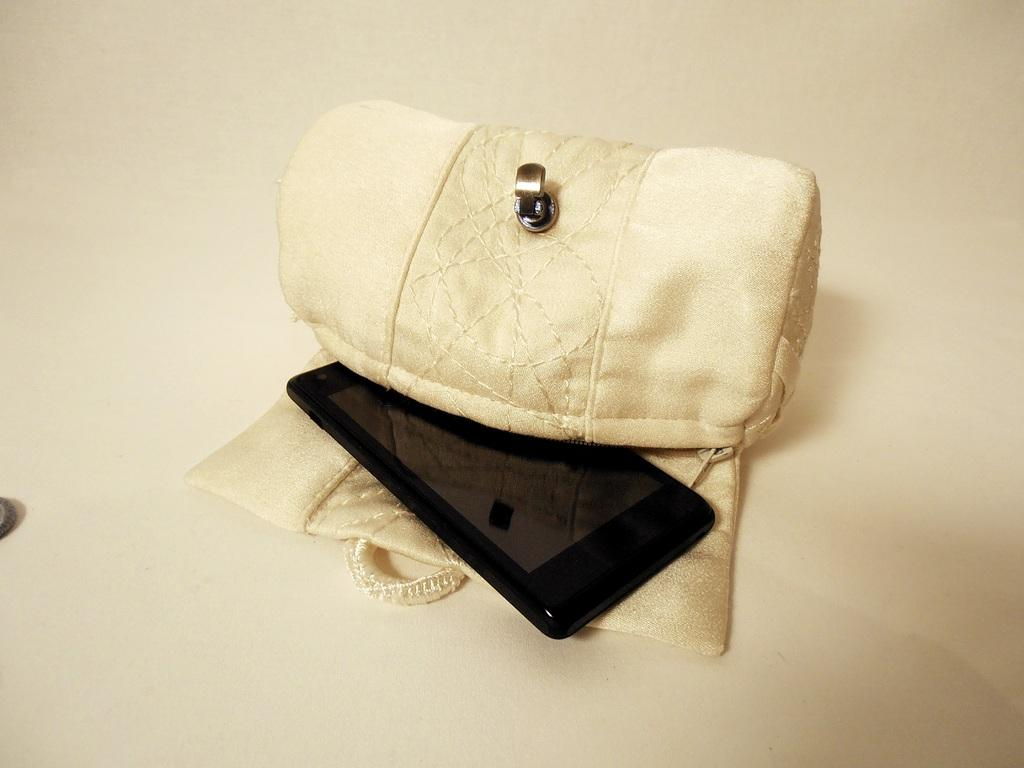What object is located in the middle of the image? There is a purse in the middle of the image. What color is the purse? The purse is cream-colored. What is inside the purse? There is a mobile in the purse. What color is the mobile? The mobile is black-colored. What type of potato is being used for the activity in the image? There is no potato or activity present in the image. Is there a club visible in the image? There is no club visible in the image. 